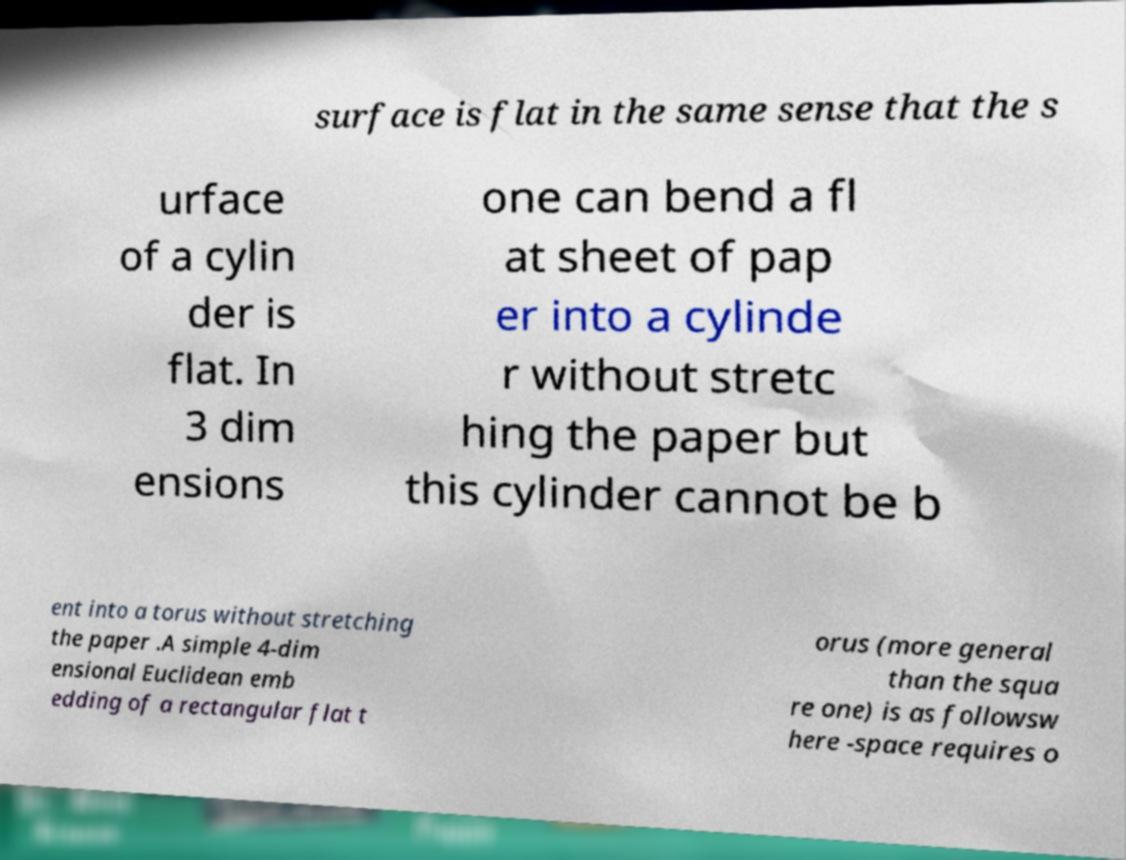I need the written content from this picture converted into text. Can you do that? surface is flat in the same sense that the s urface of a cylin der is flat. In 3 dim ensions one can bend a fl at sheet of pap er into a cylinde r without stretc hing the paper but this cylinder cannot be b ent into a torus without stretching the paper .A simple 4-dim ensional Euclidean emb edding of a rectangular flat t orus (more general than the squa re one) is as followsw here -space requires o 